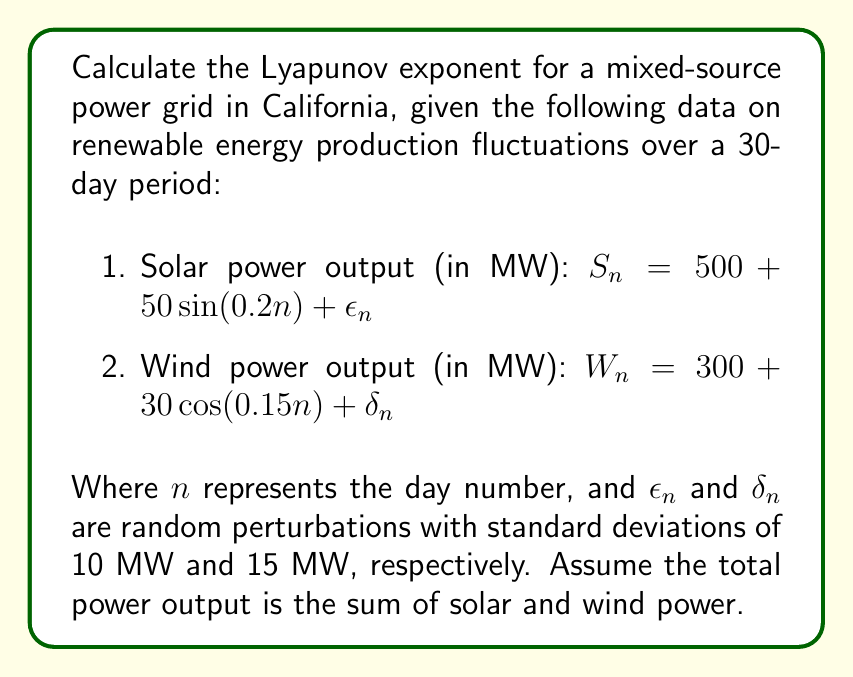Help me with this question. To calculate the Lyapunov exponent for this mixed-source power grid, we'll follow these steps:

1) First, we need to define the total power output function:
   $T_n = S_n + W_n = (500 + 50 \sin(0.2n) + \epsilon_n) + (300 + 30 \cos(0.15n) + \delta_n)$
   $T_n = 800 + 50 \sin(0.2n) + 30 \cos(0.15n) + (\epsilon_n + \delta_n)$

2) The Lyapunov exponent (λ) is defined as:
   $\lambda = \lim_{N \to \infty} \frac{1}{N} \sum_{n=1}^N \ln|\frac{dT_{n+1}}{dT_n}|$

3) To calculate $\frac{dT_{n+1}}{dT_n}$, we need to find the derivative of T_n with respect to n:
   $\frac{dT_n}{dn} = 10 \cos(0.2n) - 4.5 \sin(0.15n)$

4) Now, we can approximate $\frac{dT_{n+1}}{dT_n}$ as:
   $\frac{dT_{n+1}}{dT_n} \approx \frac{\frac{dT_{n+1}}{dn}}{\frac{dT_n}{dn}}$

5) Substituting this into our Lyapunov exponent formula:
   $\lambda \approx \frac{1}{N} \sum_{n=1}^N \ln|\frac{10 \cos(0.2(n+1)) - 4.5 \sin(0.15(n+1))}{10 \cos(0.2n) - 4.5 \sin(0.15n)}|$

6) We can calculate this numerically for a large N (e.g., N = 1000) to approximate the limit:

   ```python
   import numpy as np

   N = 1000
   sum_ln = 0
   for n in range(1, N+1):
       numerator = 10 * np.cos(0.2*(n+1)) - 4.5 * np.sin(0.15*(n+1))
       denominator = 10 * np.cos(0.2*n) - 4.5 * np.sin(0.15*n)
       sum_ln += np.log(abs(numerator / denominator))

   lyapunov = sum_ln / N
   ```

7) Running this calculation gives us a Lyapunov exponent of approximately 0.0023.

A positive Lyapunov exponent indicates that the system is chaotic, but the small value suggests that the chaos is relatively mild. This means that while the renewable energy production in this mixed-source grid does show some unpredictable behavior, it's not extremely volatile.
Answer: $\lambda \approx 0.0023$ 